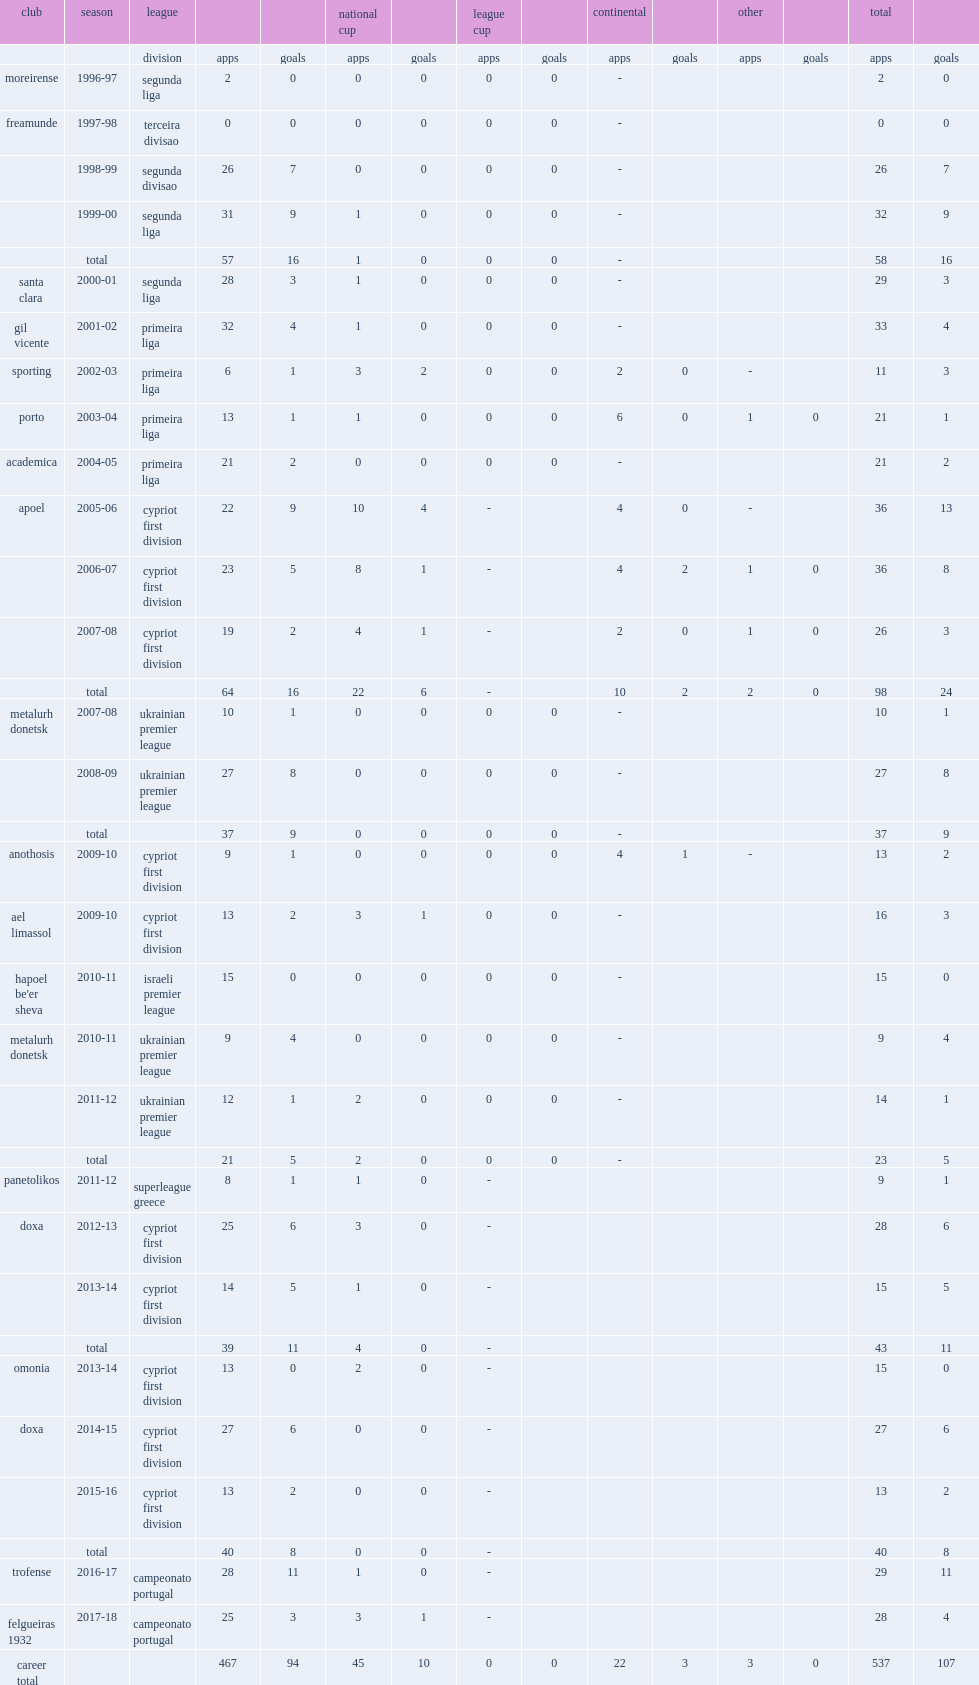Which club did gil vicente play for in 2001-02? Gil vicente. 